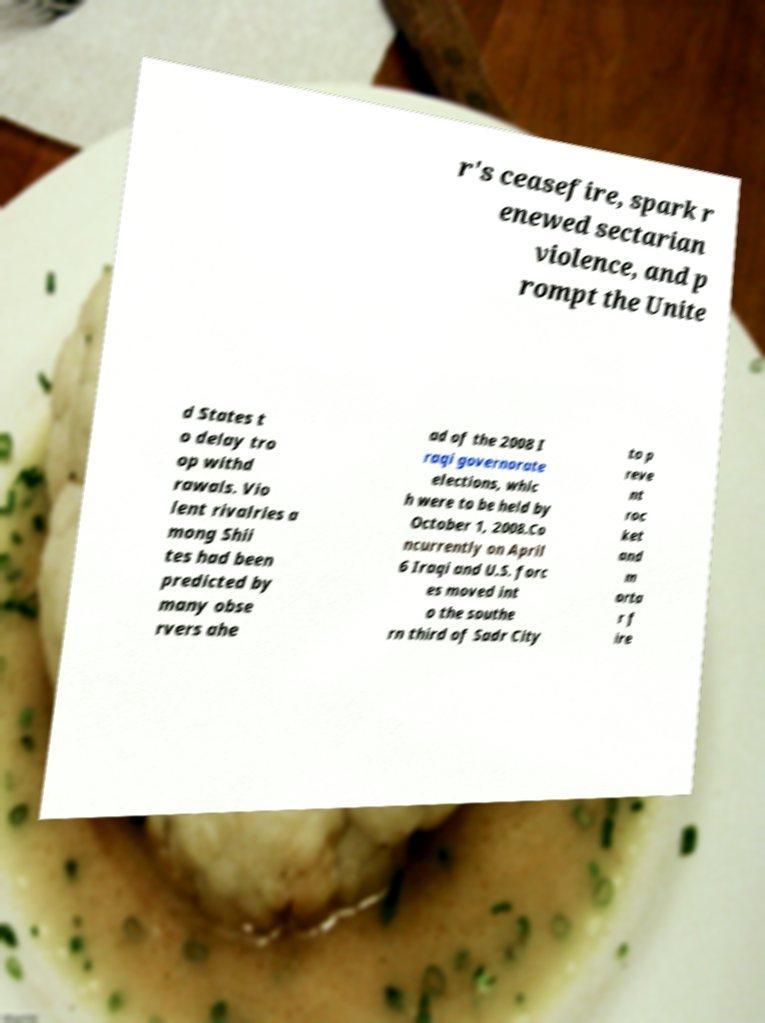Could you extract and type out the text from this image? r's ceasefire, spark r enewed sectarian violence, and p rompt the Unite d States t o delay tro op withd rawals. Vio lent rivalries a mong Shii tes had been predicted by many obse rvers ahe ad of the 2008 I raqi governorate elections, whic h were to be held by October 1, 2008.Co ncurrently on April 6 Iraqi and U.S. forc es moved int o the southe rn third of Sadr City to p reve nt roc ket and m orta r f ire 